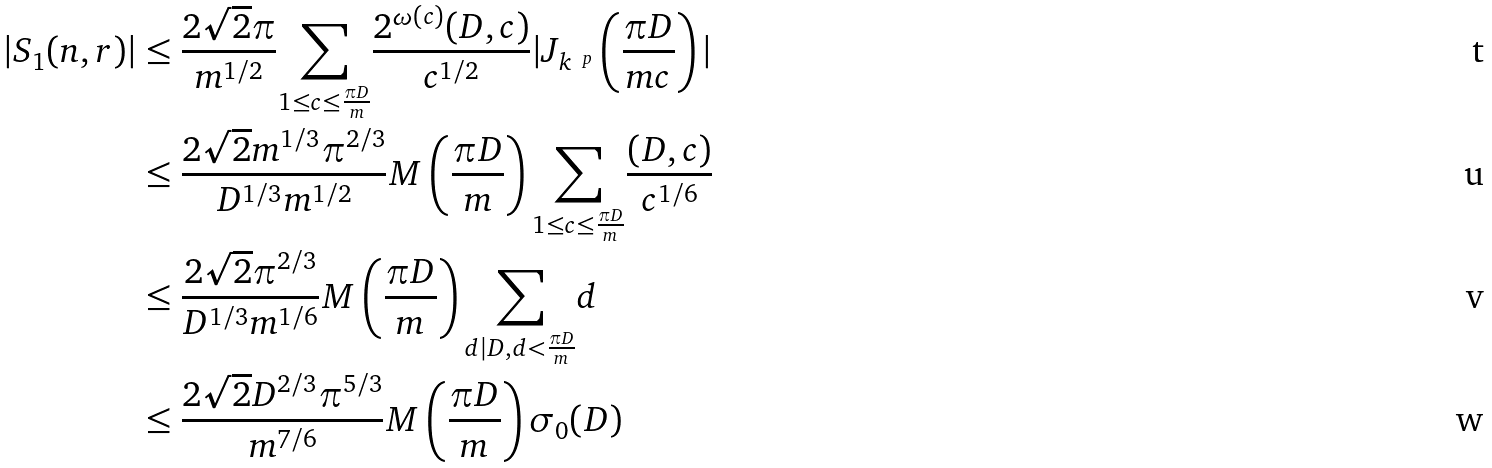<formula> <loc_0><loc_0><loc_500><loc_500>| S _ { 1 } ( n , r ) | & \leq \frac { 2 \sqrt { 2 } \pi } { m ^ { 1 / 2 } } \underset { 1 \leq c \leq \frac { \pi D } { m } } \sum \frac { 2 ^ { \omega ( c ) } ( D , c ) } { c ^ { 1 / 2 } } | J _ { k ^ { \ p } } \left ( \frac { \pi D } { m c } \right ) | \\ & \leq \frac { 2 \sqrt { 2 } m ^ { 1 / 3 } \pi ^ { 2 / 3 } } { D ^ { 1 / 3 } m ^ { 1 / 2 } } M \left ( \frac { \pi D } { m } \right ) \underset { 1 \leq c \leq \frac { \pi D } { m } } \sum \frac { ( D , c ) } { c ^ { 1 / 6 } } \\ & \leq \frac { 2 \sqrt { 2 } \pi ^ { 2 / 3 } } { D ^ { 1 / 3 } m ^ { 1 / 6 } } M \left ( \frac { \pi D } { m } \right ) \underset { d | D , d < \frac { \pi D } { m } } \sum d \\ & \leq \frac { 2 \sqrt { 2 } D ^ { 2 / 3 } \pi ^ { 5 / 3 } } { m ^ { 7 / 6 } } M \left ( \frac { \pi D } { m } \right ) \sigma _ { 0 } ( D )</formula> 